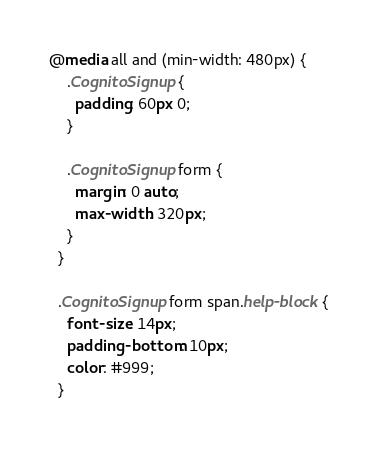Convert code to text. <code><loc_0><loc_0><loc_500><loc_500><_CSS_>@media all and (min-width: 480px) {
    .CognitoSignup {
      padding: 60px 0;
    }
  
    .CognitoSignup form {
      margin: 0 auto;
      max-width: 320px;
    }
  }
  
  .CognitoSignup form span.help-block {
    font-size: 14px;
    padding-bottom: 10px;
    color: #999;
  }
  </code> 